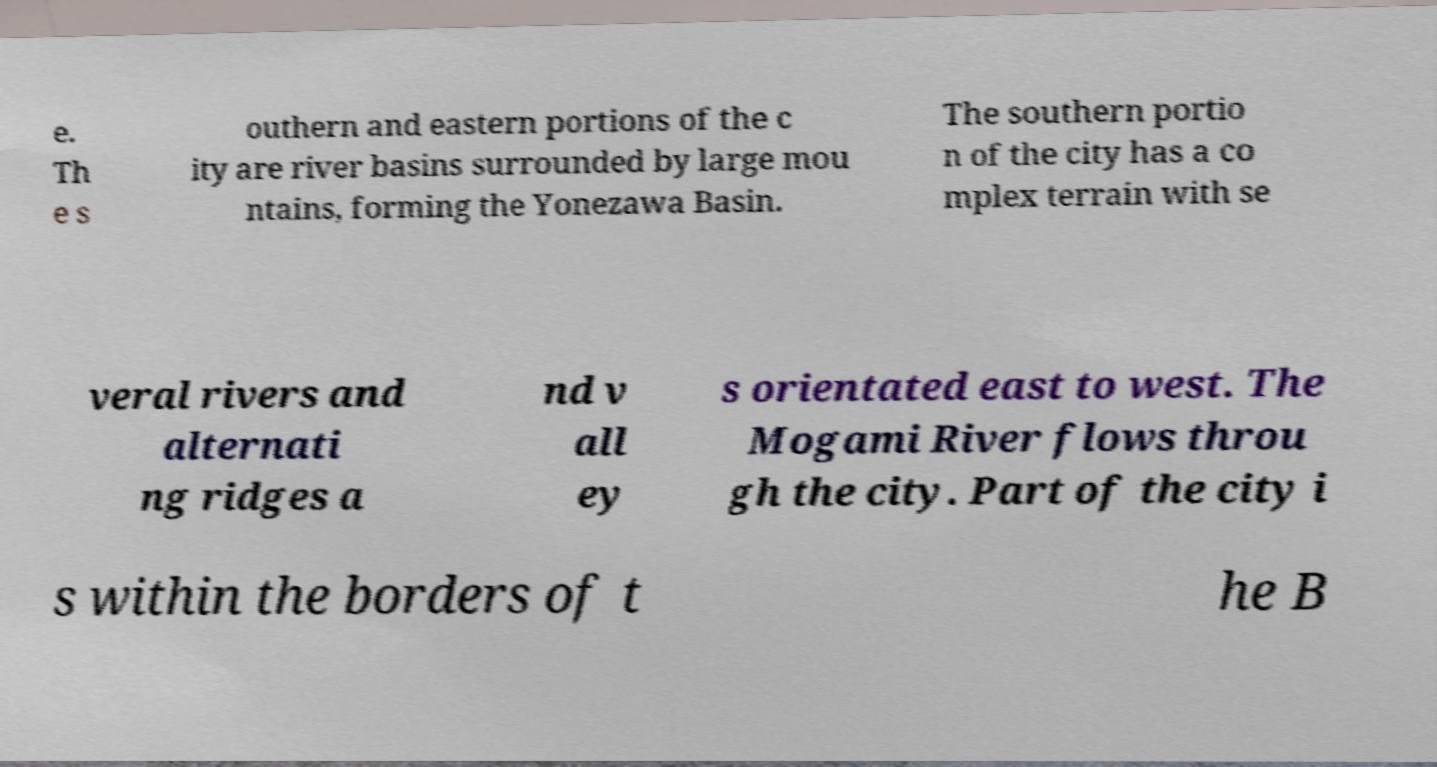What messages or text are displayed in this image? I need them in a readable, typed format. e. Th e s outhern and eastern portions of the c ity are river basins surrounded by large mou ntains, forming the Yonezawa Basin. The southern portio n of the city has a co mplex terrain with se veral rivers and alternati ng ridges a nd v all ey s orientated east to west. The Mogami River flows throu gh the city. Part of the city i s within the borders of t he B 